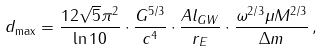Convert formula to latex. <formula><loc_0><loc_0><loc_500><loc_500>d _ { \max } = \frac { 1 2 \sqrt { 5 } \pi ^ { 2 } } { \ln 1 0 } \cdot \frac { G ^ { 5 / 3 } } { c ^ { 4 } } \cdot \frac { A l _ { G W } } { r _ { E } } \cdot \frac { \omega ^ { 2 / 3 } \mu M ^ { 2 / 3 } } { \Delta m } \, ,</formula> 